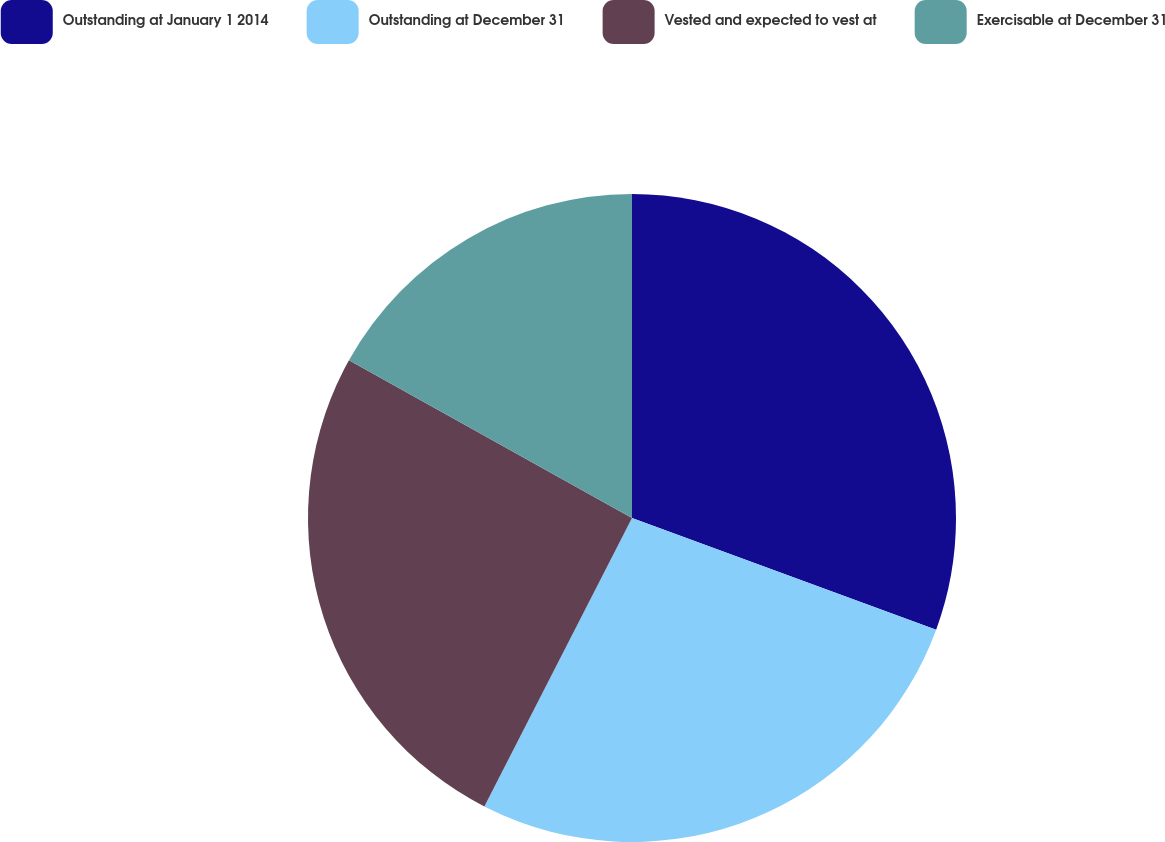Convert chart. <chart><loc_0><loc_0><loc_500><loc_500><pie_chart><fcel>Outstanding at January 1 2014<fcel>Outstanding at December 31<fcel>Vested and expected to vest at<fcel>Exercisable at December 31<nl><fcel>30.6%<fcel>26.93%<fcel>25.56%<fcel>16.91%<nl></chart> 